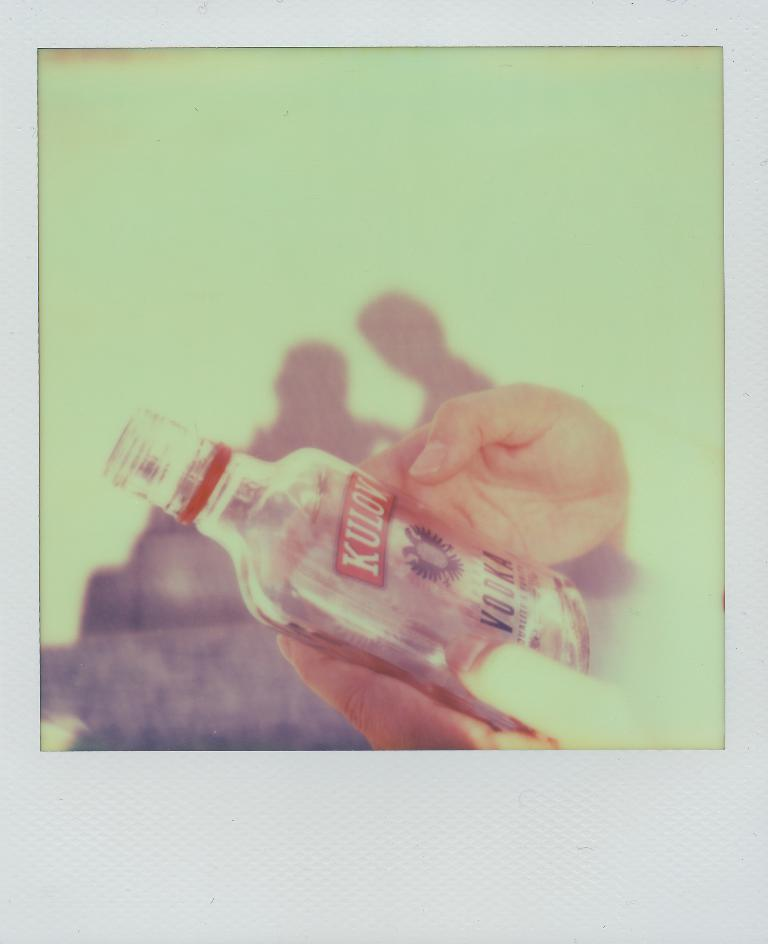Who or what is present in the image? There is a person in the image. What is the person holding in the image? The person is holding a bottle. What type of religious symbol can be seen on the person's feet in the image? There is no religious symbol or mention of feet in the image; it only features a person holding a bottle. 